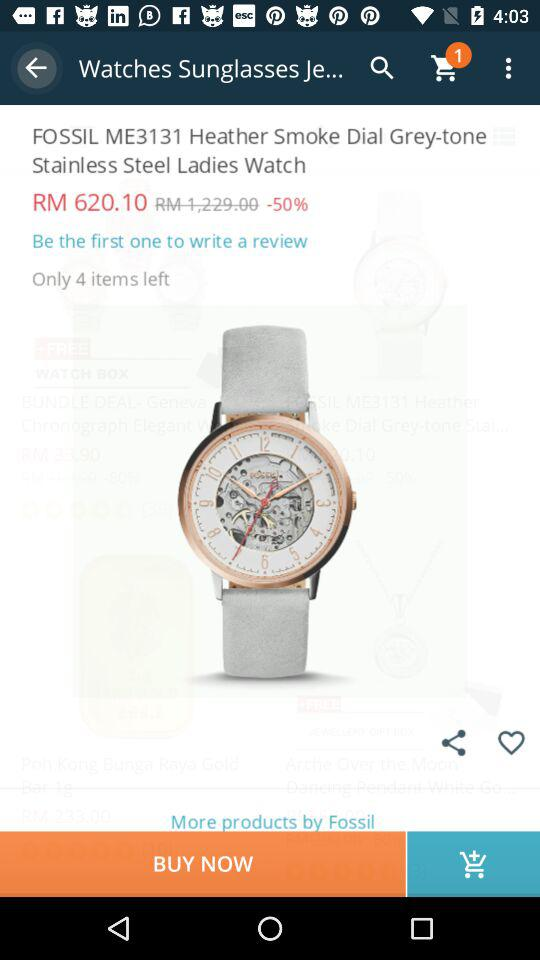How much is the original price of the product?
Answer the question using a single word or phrase. RM 1,229.00 